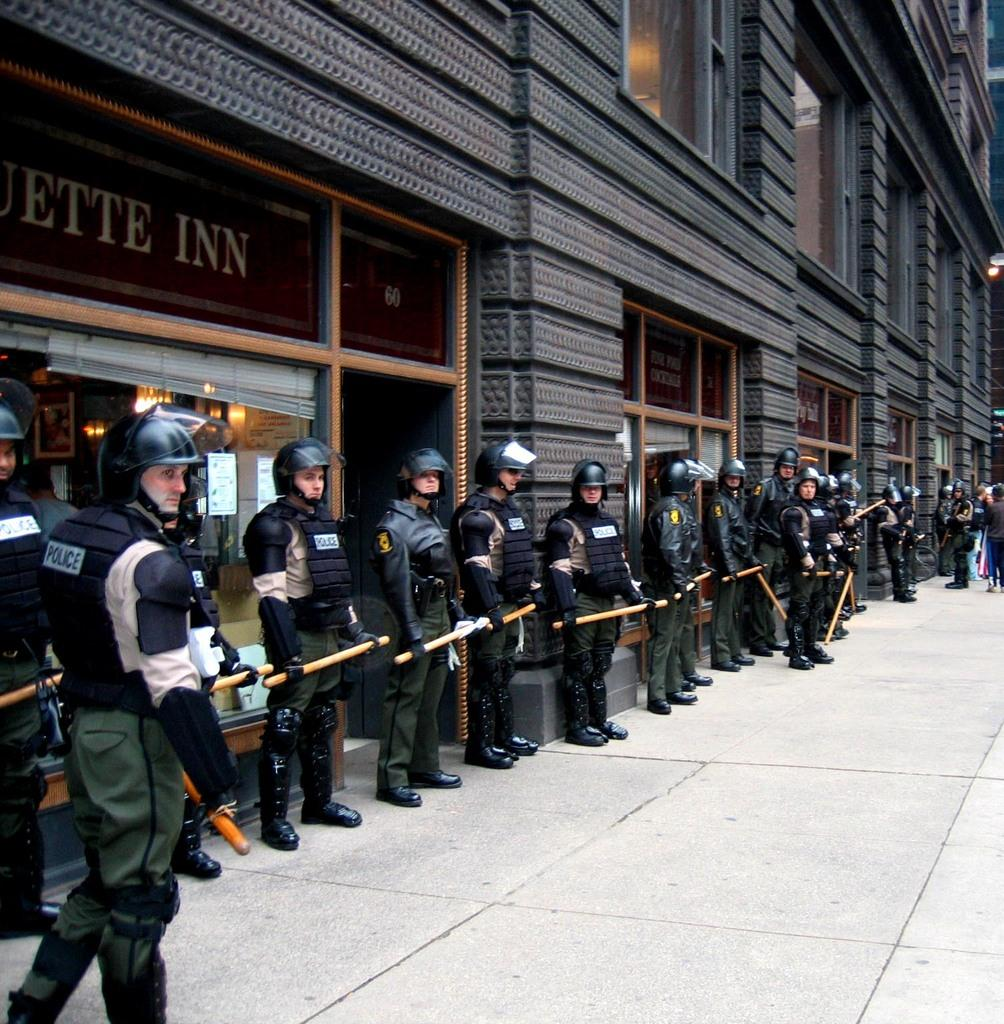How many people are in the image? There is a group of people in the image, but the exact number is not specified. What are the people doing in the image? The people are standing on the ground and holding sticks. What can be seen in the background of the image? There is a building, posters, and lights in the image. What type of weather can be seen in the image? The provided facts do not mention any weather conditions in the image. Can you tell me how many rays are coming from the lights in the image? The number of rays coming from the lights is not specified in the image. 